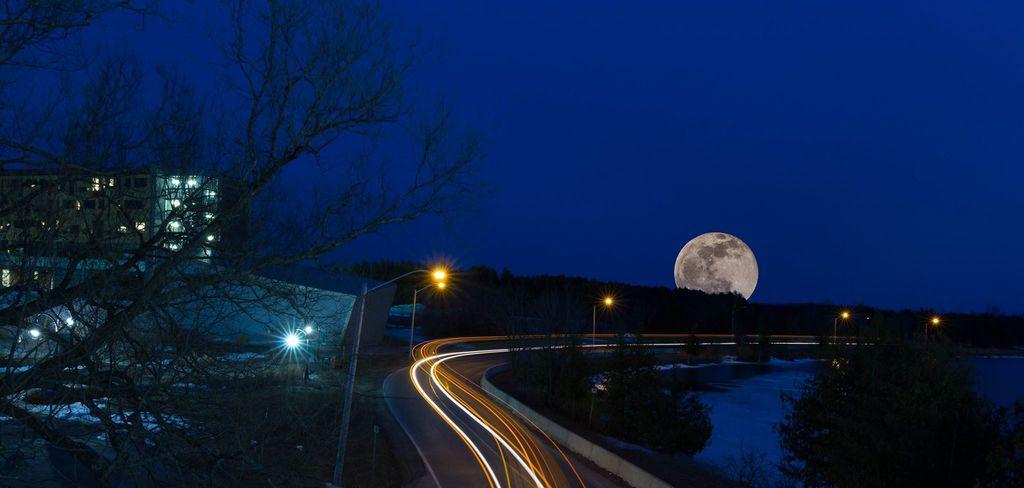Describe this image in one or two sentences. In this picture we can see water and trees on the right side, on the left side we can see a building and a trees, in the background there are some poles, lights, trees and the moon, there is the sky at the top of the picture. 